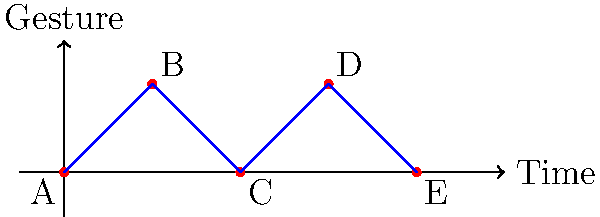In a series of surveillance footage stills, a suspect's hand gestures are plotted over time as shown in the graph. Each peak represents a raised hand, while valleys indicate lowered hands. Based on this pattern, what is the most likely sequence of gestures the suspect is using to communicate? To decode the gesture sequence, we need to analyze the graph step-by-step:

1. Understand the graph:
   - The x-axis represents time progression.
   - The y-axis represents the hand position (raised or lowered).
   - Peaks (high points) indicate raised hands, valleys (low points) indicate lowered hands.

2. Identify the gesture sequence:
   A. Start with a lowered hand (0,0)
   B. Raise the hand (1,1)
   C. Lower the hand (2,0)
   D. Raise the hand again (3,1)
   E. Finally, lower the hand (4,0)

3. Interpret the sequence:
   - This pattern of "low-high-low-high-low" is commonly associated with a simple binary code.
   - In many covert communication systems, raised hands often represent "1" or "on," while lowered hands represent "0" or "off."

4. Translate to binary:
   The sequence translates to: 0 1 0 1 0

5. Conclude:
   This binary sequence (01010) is likely a predetermined code used for covert communication. It could represent a specific message, action, or be part of a larger sequence.

Given the context of interpreting testimonies and surveillance footage, this gesture sequence is most likely a deliberate, coded message rather than random movements.
Answer: Binary code: 01010 